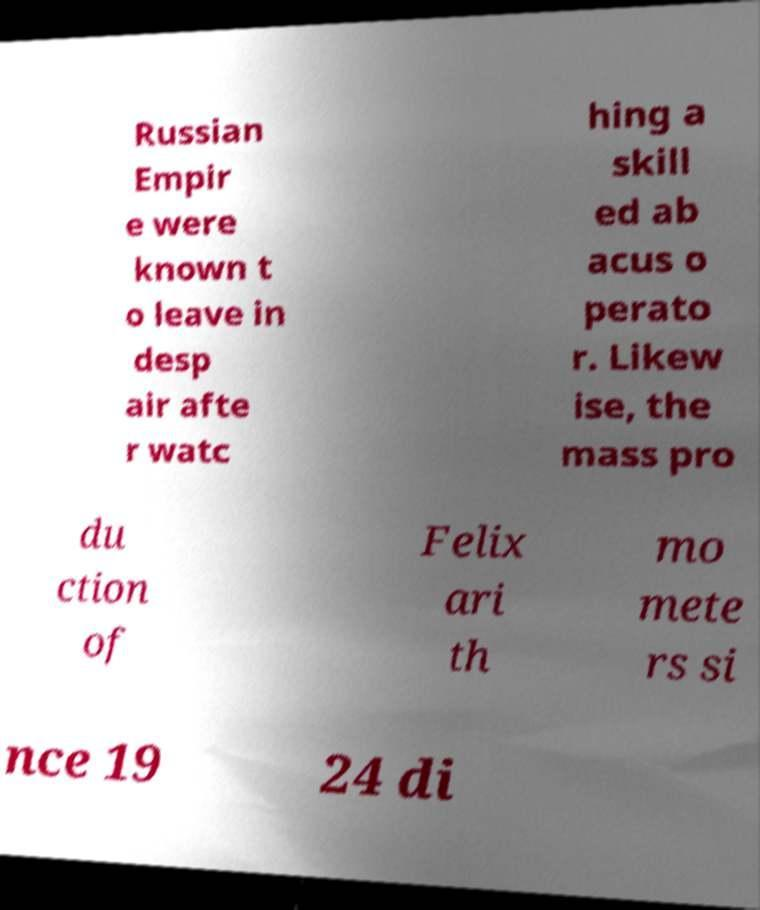Please identify and transcribe the text found in this image. Russian Empir e were known t o leave in desp air afte r watc hing a skill ed ab acus o perato r. Likew ise, the mass pro du ction of Felix ari th mo mete rs si nce 19 24 di 